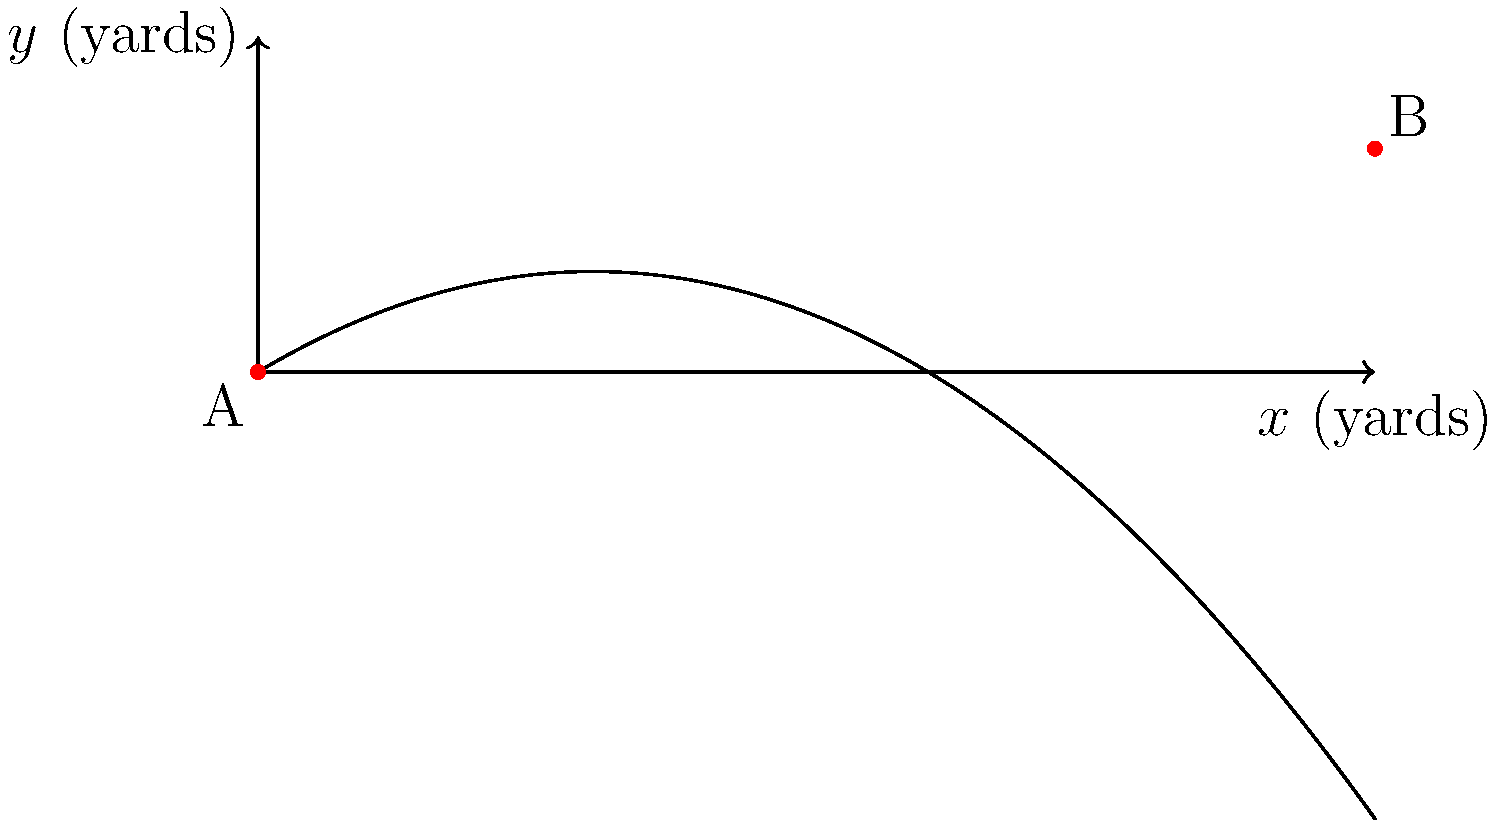In a crucial game against a rival team, you need to design a long passing play. The trajectory of the football can be modeled by the parabolic function $f(x) = -0.02x^2 + 0.6x$, where $x$ is the horizontal distance in yards and $f(x)$ is the height in yards. If the receiver is 50 yards downfield, what is the maximum height the football reaches during its flight? To find the maximum height of the football's trajectory, we need to follow these steps:

1) The parabola's equation is given as $f(x) = -0.02x^2 + 0.6x$.

2) For a parabola $f(x) = ax^2 + bx + c$, the x-coordinate of the vertex is given by $x = -\frac{b}{2a}$.

3) In our case, $a = -0.02$ and $b = 0.6$. Let's calculate the x-coordinate of the vertex:

   $x = -\frac{0.6}{2(-0.02)} = -\frac{0.6}{-0.04} = 15$ yards

4) To find the maximum height, we need to plug this x-value back into our original function:

   $f(15) = -0.02(15)^2 + 0.6(15)$
   $= -0.02(225) + 9$
   $= -4.5 + 9$
   $= 4.5$ yards

Therefore, the maximum height the football reaches is 4.5 yards.
Answer: 4.5 yards 